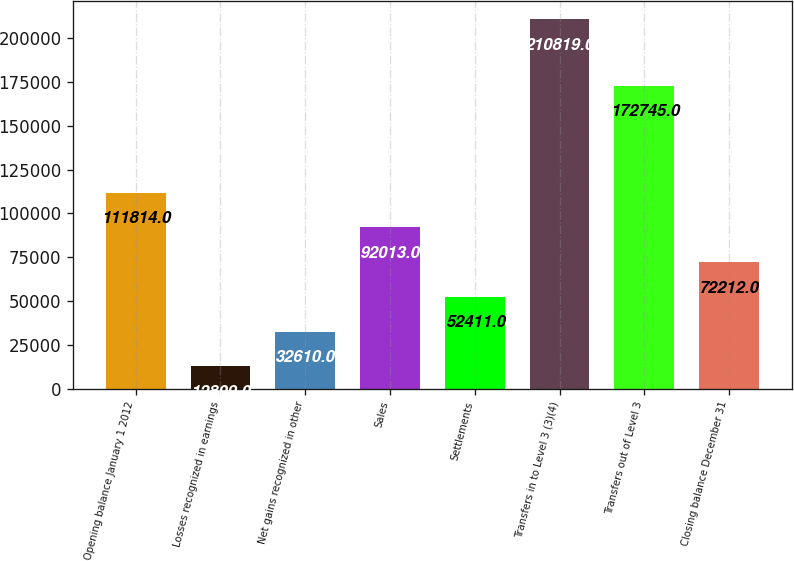<chart> <loc_0><loc_0><loc_500><loc_500><bar_chart><fcel>Opening balance January 1 2012<fcel>Losses recognized in earnings<fcel>Net gains recognized in other<fcel>Sales<fcel>Settlements<fcel>Transfers in to Level 3 (3)(4)<fcel>Transfers out of Level 3<fcel>Closing balance December 31<nl><fcel>111814<fcel>12809<fcel>32610<fcel>92013<fcel>52411<fcel>210819<fcel>172745<fcel>72212<nl></chart> 